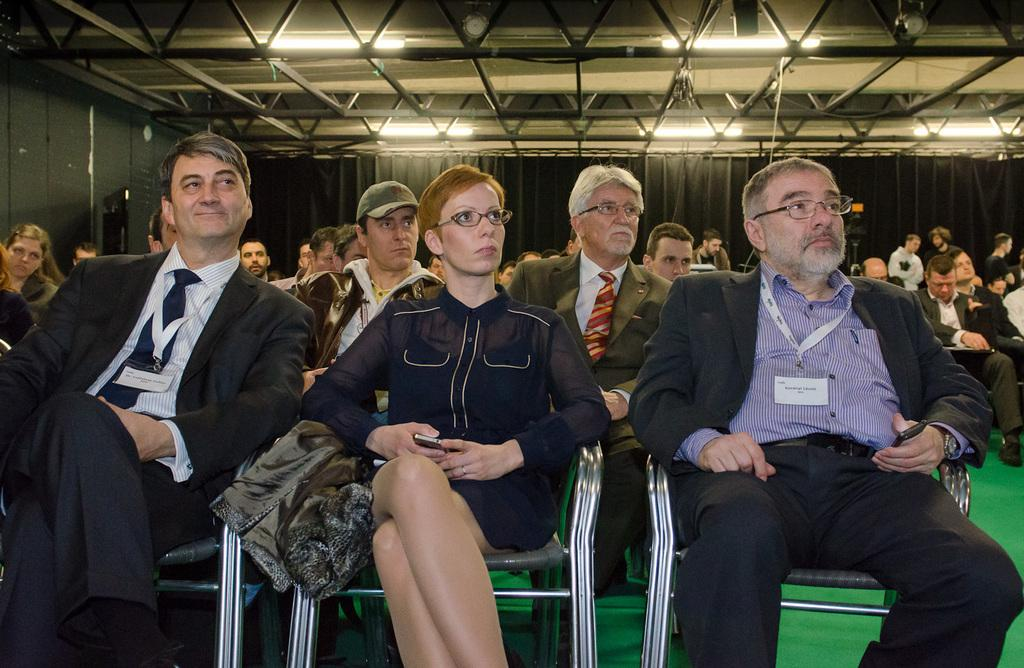What are the persons in the image doing? The persons in the image are sitting in chairs. Can you describe any other objects or features in the image? There are other objects in the background, but their specific details are not mentioned in the provided facts. How many yams are being requested by the sisters in the image? There are no yams or sisters mentioned in the image, so this question cannot be answered. 